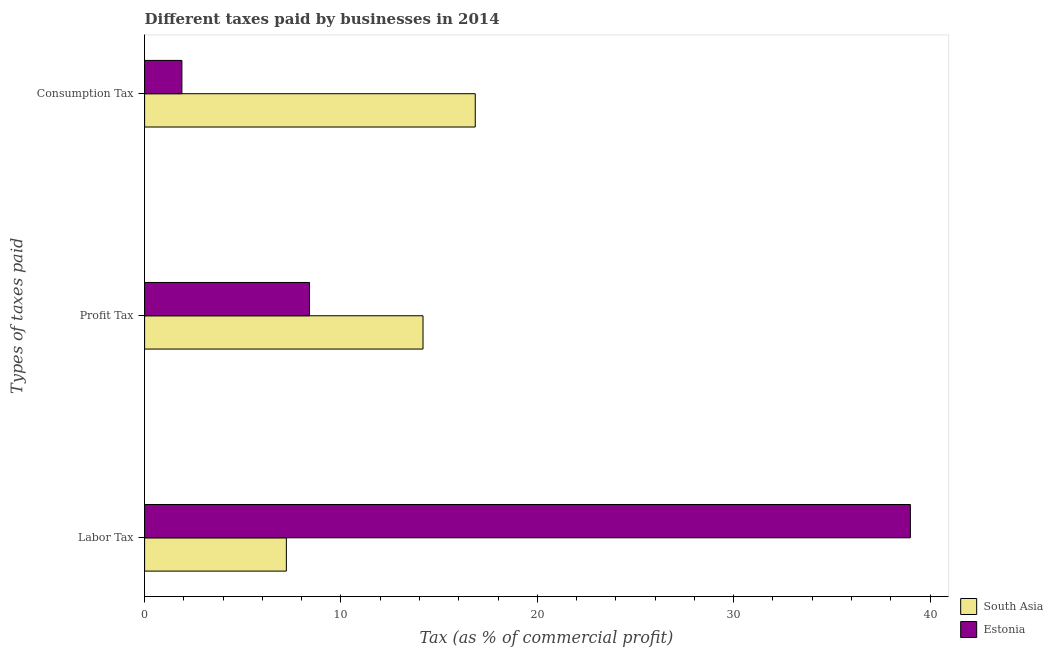Are the number of bars per tick equal to the number of legend labels?
Offer a very short reply. Yes. How many bars are there on the 1st tick from the top?
Your answer should be very brief. 2. How many bars are there on the 2nd tick from the bottom?
Your answer should be very brief. 2. What is the label of the 1st group of bars from the top?
Keep it short and to the point. Consumption Tax. What is the percentage of consumption tax in South Asia?
Your response must be concise. 16.84. Across all countries, what is the maximum percentage of labor tax?
Your response must be concise. 39. Across all countries, what is the minimum percentage of labor tax?
Make the answer very short. 7.22. In which country was the percentage of consumption tax minimum?
Your response must be concise. Estonia. What is the total percentage of labor tax in the graph?
Offer a very short reply. 46.22. What is the difference between the percentage of consumption tax in Estonia and that in South Asia?
Give a very brief answer. -14.94. What is the difference between the percentage of labor tax in South Asia and the percentage of profit tax in Estonia?
Provide a succinct answer. -1.18. What is the average percentage of consumption tax per country?
Ensure brevity in your answer.  9.37. What is the difference between the percentage of labor tax and percentage of profit tax in Estonia?
Your response must be concise. 30.6. In how many countries, is the percentage of consumption tax greater than 18 %?
Offer a very short reply. 0. What is the ratio of the percentage of profit tax in South Asia to that in Estonia?
Provide a succinct answer. 1.69. What is the difference between the highest and the second highest percentage of labor tax?
Make the answer very short. 31.78. What is the difference between the highest and the lowest percentage of consumption tax?
Your answer should be compact. 14.94. What does the 1st bar from the top in Labor Tax represents?
Provide a succinct answer. Estonia. Is it the case that in every country, the sum of the percentage of labor tax and percentage of profit tax is greater than the percentage of consumption tax?
Your response must be concise. Yes. Are all the bars in the graph horizontal?
Your answer should be very brief. Yes. Does the graph contain any zero values?
Your response must be concise. No. Does the graph contain grids?
Your answer should be compact. No. Where does the legend appear in the graph?
Offer a terse response. Bottom right. How many legend labels are there?
Provide a short and direct response. 2. What is the title of the graph?
Make the answer very short. Different taxes paid by businesses in 2014. What is the label or title of the X-axis?
Provide a short and direct response. Tax (as % of commercial profit). What is the label or title of the Y-axis?
Make the answer very short. Types of taxes paid. What is the Tax (as % of commercial profit) of South Asia in Labor Tax?
Your answer should be compact. 7.22. What is the Tax (as % of commercial profit) in Estonia in Labor Tax?
Your answer should be compact. 39. What is the Tax (as % of commercial profit) of South Asia in Profit Tax?
Ensure brevity in your answer.  14.18. What is the Tax (as % of commercial profit) of Estonia in Profit Tax?
Give a very brief answer. 8.4. What is the Tax (as % of commercial profit) in South Asia in Consumption Tax?
Offer a very short reply. 16.84. What is the Tax (as % of commercial profit) in Estonia in Consumption Tax?
Give a very brief answer. 1.9. Across all Types of taxes paid, what is the maximum Tax (as % of commercial profit) of South Asia?
Ensure brevity in your answer.  16.84. Across all Types of taxes paid, what is the minimum Tax (as % of commercial profit) in South Asia?
Offer a terse response. 7.22. What is the total Tax (as % of commercial profit) in South Asia in the graph?
Offer a terse response. 38.24. What is the total Tax (as % of commercial profit) of Estonia in the graph?
Provide a succinct answer. 49.3. What is the difference between the Tax (as % of commercial profit) of South Asia in Labor Tax and that in Profit Tax?
Give a very brief answer. -6.96. What is the difference between the Tax (as % of commercial profit) in Estonia in Labor Tax and that in Profit Tax?
Provide a short and direct response. 30.6. What is the difference between the Tax (as % of commercial profit) of South Asia in Labor Tax and that in Consumption Tax?
Your answer should be compact. -9.62. What is the difference between the Tax (as % of commercial profit) of Estonia in Labor Tax and that in Consumption Tax?
Your response must be concise. 37.1. What is the difference between the Tax (as % of commercial profit) of South Asia in Profit Tax and that in Consumption Tax?
Offer a very short reply. -2.66. What is the difference between the Tax (as % of commercial profit) in South Asia in Labor Tax and the Tax (as % of commercial profit) in Estonia in Profit Tax?
Your answer should be compact. -1.18. What is the difference between the Tax (as % of commercial profit) of South Asia in Labor Tax and the Tax (as % of commercial profit) of Estonia in Consumption Tax?
Keep it short and to the point. 5.32. What is the difference between the Tax (as % of commercial profit) of South Asia in Profit Tax and the Tax (as % of commercial profit) of Estonia in Consumption Tax?
Ensure brevity in your answer.  12.28. What is the average Tax (as % of commercial profit) in South Asia per Types of taxes paid?
Give a very brief answer. 12.75. What is the average Tax (as % of commercial profit) in Estonia per Types of taxes paid?
Give a very brief answer. 16.43. What is the difference between the Tax (as % of commercial profit) of South Asia and Tax (as % of commercial profit) of Estonia in Labor Tax?
Your response must be concise. -31.78. What is the difference between the Tax (as % of commercial profit) of South Asia and Tax (as % of commercial profit) of Estonia in Profit Tax?
Offer a very short reply. 5.78. What is the difference between the Tax (as % of commercial profit) of South Asia and Tax (as % of commercial profit) of Estonia in Consumption Tax?
Your answer should be compact. 14.94. What is the ratio of the Tax (as % of commercial profit) of South Asia in Labor Tax to that in Profit Tax?
Provide a short and direct response. 0.51. What is the ratio of the Tax (as % of commercial profit) of Estonia in Labor Tax to that in Profit Tax?
Provide a short and direct response. 4.64. What is the ratio of the Tax (as % of commercial profit) in South Asia in Labor Tax to that in Consumption Tax?
Your answer should be very brief. 0.43. What is the ratio of the Tax (as % of commercial profit) in Estonia in Labor Tax to that in Consumption Tax?
Provide a short and direct response. 20.53. What is the ratio of the Tax (as % of commercial profit) of South Asia in Profit Tax to that in Consumption Tax?
Provide a short and direct response. 0.84. What is the ratio of the Tax (as % of commercial profit) in Estonia in Profit Tax to that in Consumption Tax?
Offer a terse response. 4.42. What is the difference between the highest and the second highest Tax (as % of commercial profit) of South Asia?
Provide a succinct answer. 2.66. What is the difference between the highest and the second highest Tax (as % of commercial profit) of Estonia?
Ensure brevity in your answer.  30.6. What is the difference between the highest and the lowest Tax (as % of commercial profit) of South Asia?
Provide a short and direct response. 9.62. What is the difference between the highest and the lowest Tax (as % of commercial profit) in Estonia?
Your response must be concise. 37.1. 